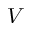<formula> <loc_0><loc_0><loc_500><loc_500>V</formula> 